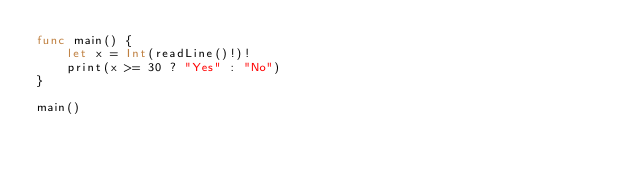Convert code to text. <code><loc_0><loc_0><loc_500><loc_500><_Swift_>func main() {
    let x = Int(readLine()!)!
    print(x >= 30 ? "Yes" : "No")
}

main()

</code> 